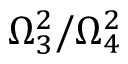Convert formula to latex. <formula><loc_0><loc_0><loc_500><loc_500>\Omega _ { 3 } ^ { 2 } / \Omega _ { 4 } ^ { 2 }</formula> 